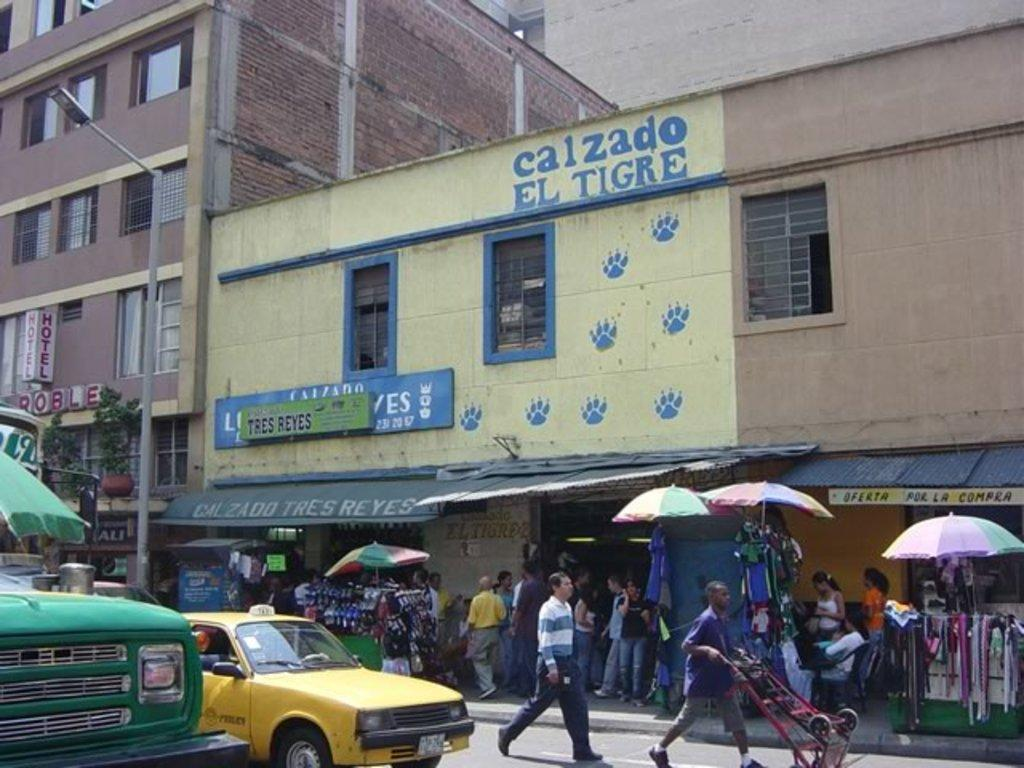Provide a one-sentence caption for the provided image. A busy city street teems with people in front of a building called Calzado el Tigre. 